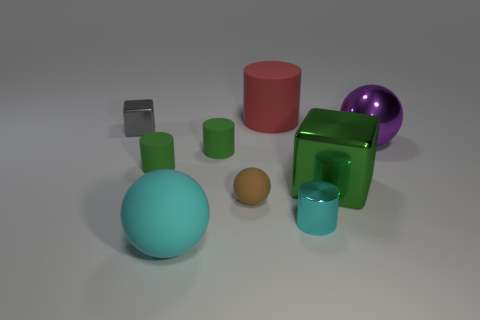How big is the cyan rubber object on the left side of the big rubber thing behind the tiny cube?
Your answer should be compact. Large. There is a rubber object that is in front of the brown sphere; is its size the same as the small metal cylinder?
Provide a succinct answer. No. Are there an equal number of gray blocks on the right side of the tiny brown thing and shiny blocks?
Provide a short and direct response. No. Is the big cube the same color as the big shiny sphere?
Make the answer very short. No. How big is the cylinder that is both behind the big green metal cube and to the right of the brown matte sphere?
Provide a succinct answer. Large. There is a sphere that is made of the same material as the gray thing; what color is it?
Provide a short and direct response. Purple. How many green cylinders are made of the same material as the tiny brown sphere?
Provide a succinct answer. 2. Are there the same number of big green shiny things behind the big green block and balls to the left of the large red matte cylinder?
Provide a succinct answer. No. Does the brown rubber object have the same shape as the big rubber object that is in front of the purple metallic object?
Keep it short and to the point. Yes. What is the material of the sphere that is the same color as the small shiny cylinder?
Provide a short and direct response. Rubber. 